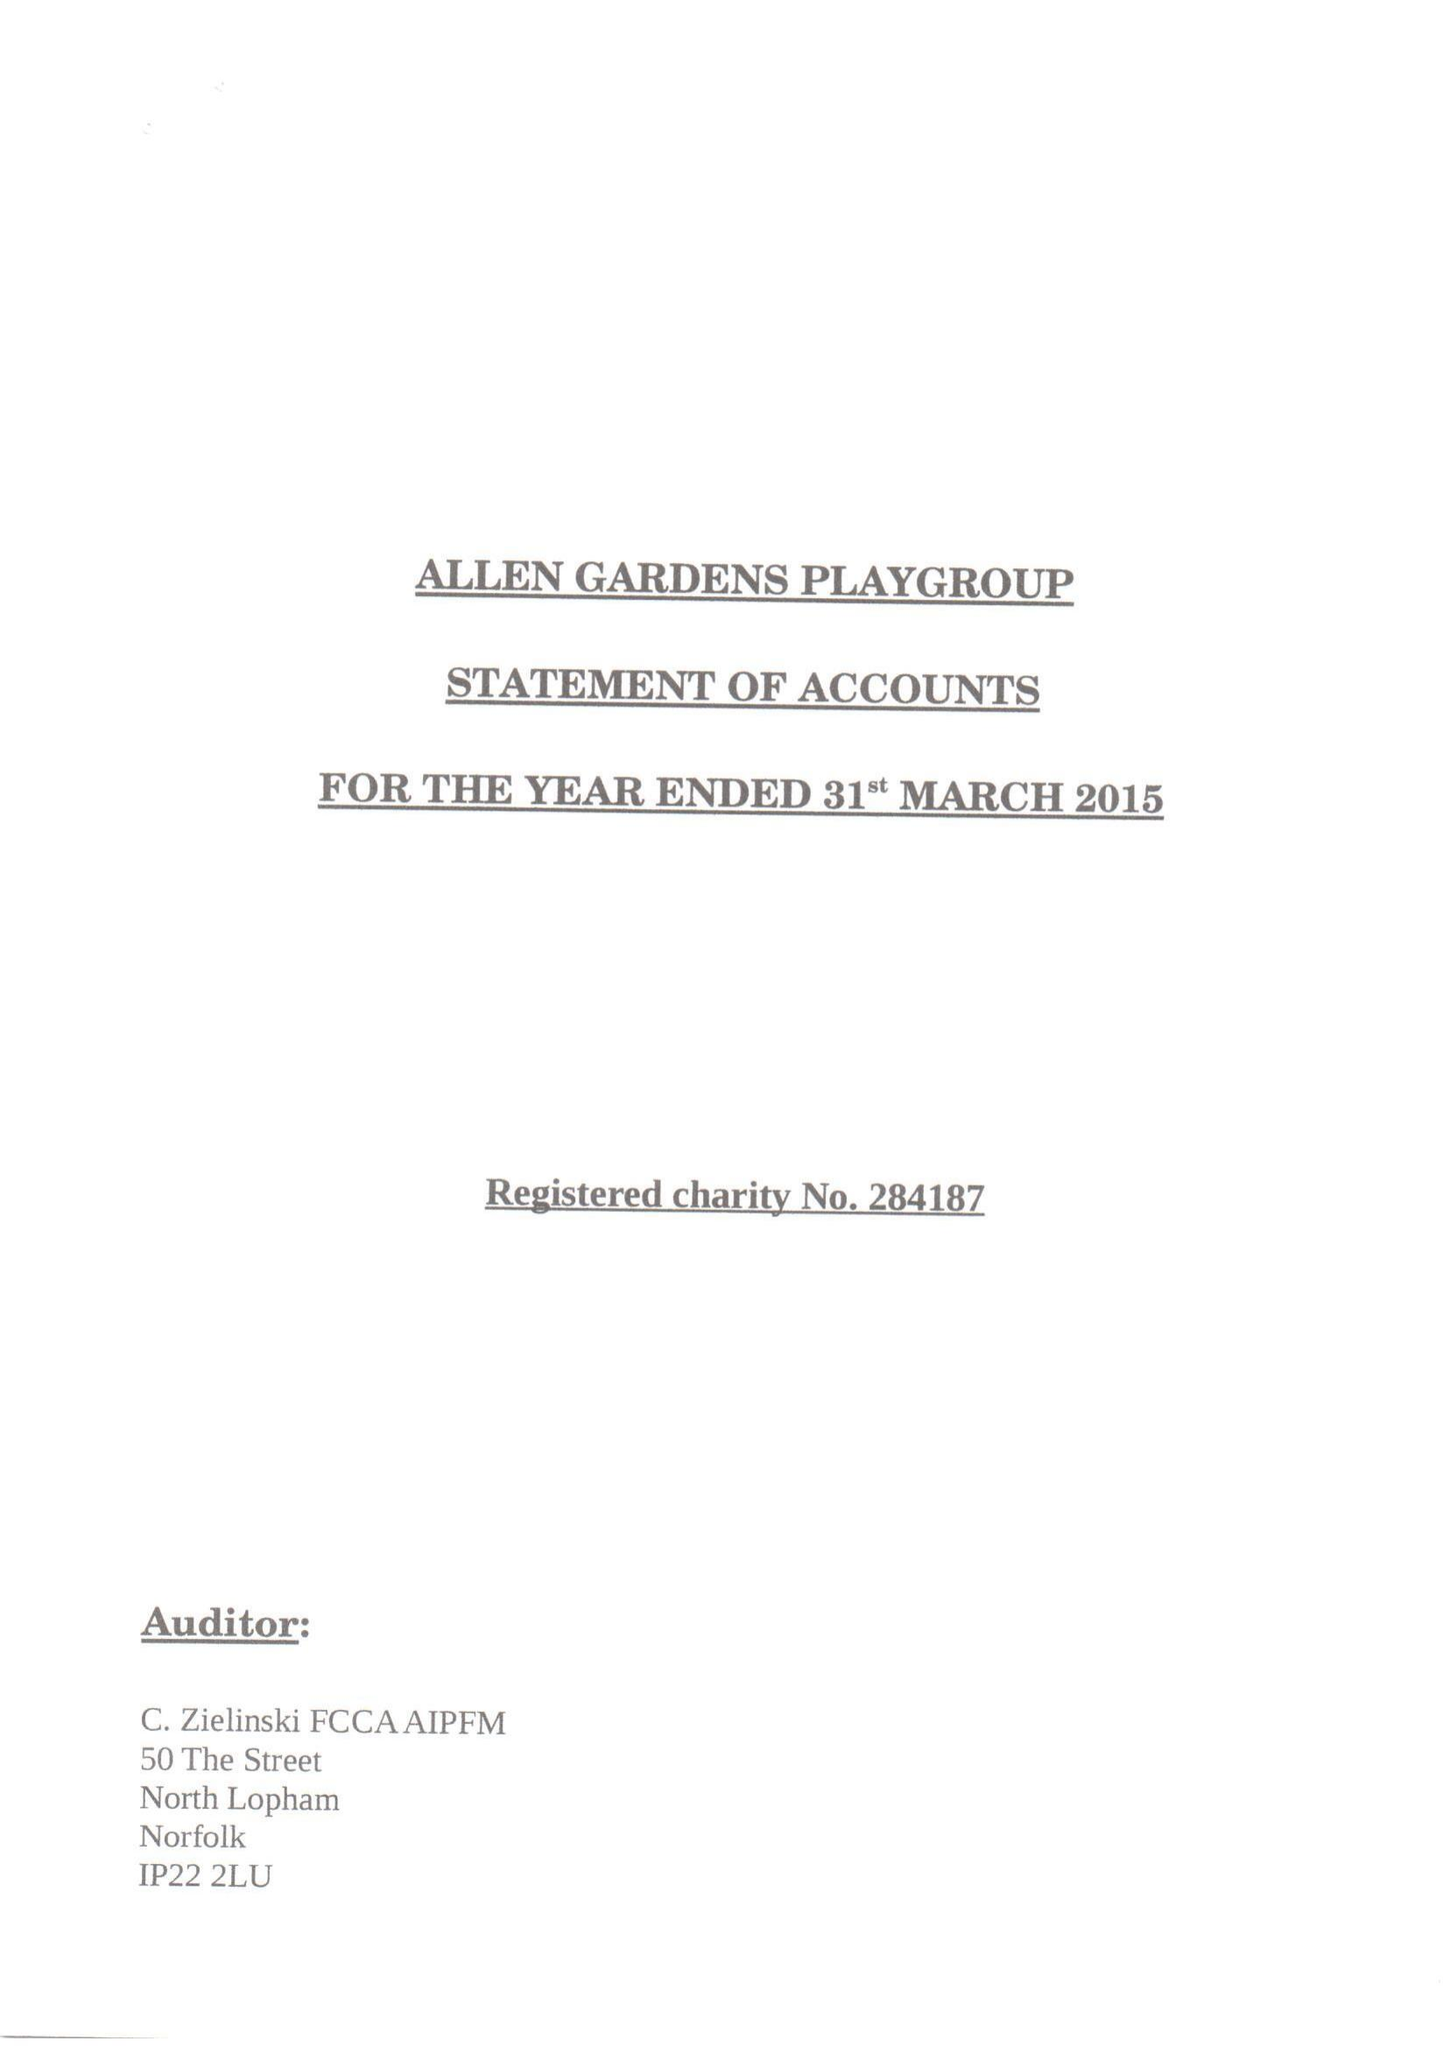What is the value for the report_date?
Answer the question using a single word or phrase. 2015-03-31 